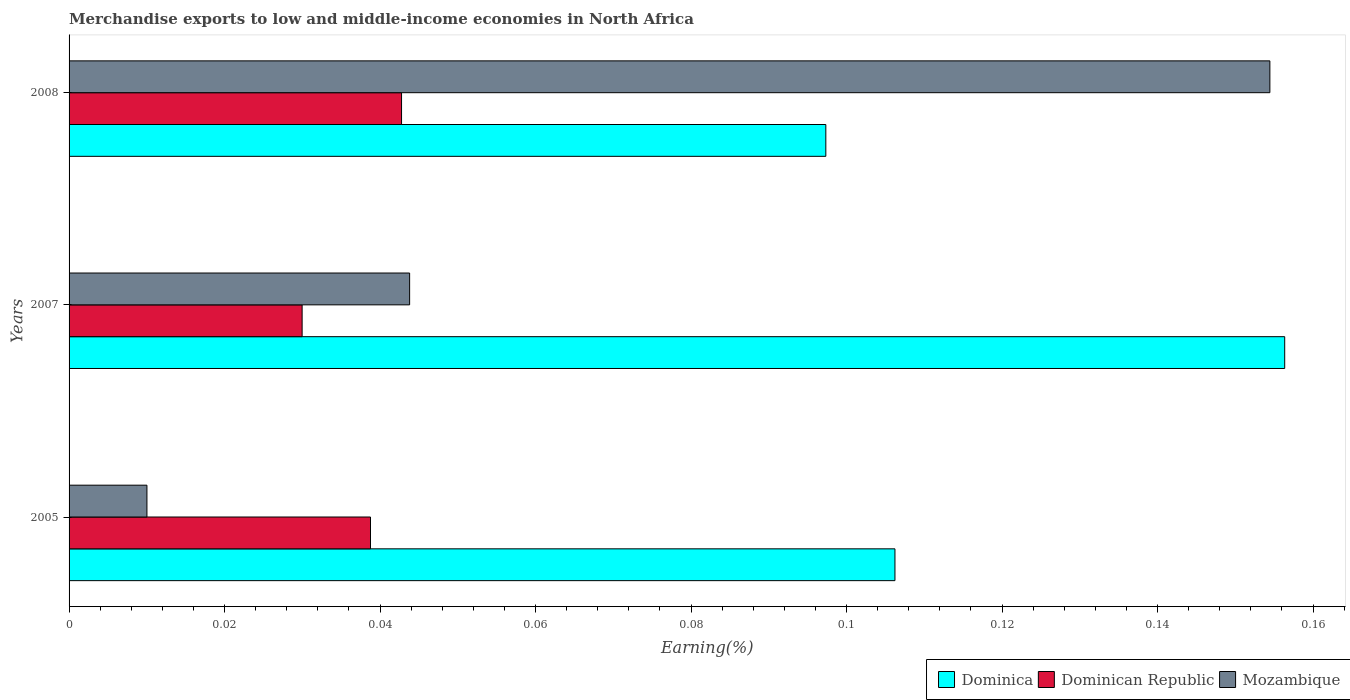How many different coloured bars are there?
Your answer should be very brief. 3. Are the number of bars on each tick of the Y-axis equal?
Your response must be concise. Yes. How many bars are there on the 2nd tick from the bottom?
Your response must be concise. 3. What is the label of the 2nd group of bars from the top?
Your response must be concise. 2007. In how many cases, is the number of bars for a given year not equal to the number of legend labels?
Your response must be concise. 0. What is the percentage of amount earned from merchandise exports in Mozambique in 2005?
Your answer should be compact. 0.01. Across all years, what is the maximum percentage of amount earned from merchandise exports in Dominican Republic?
Make the answer very short. 0.04. Across all years, what is the minimum percentage of amount earned from merchandise exports in Dominica?
Offer a very short reply. 0.1. In which year was the percentage of amount earned from merchandise exports in Mozambique maximum?
Offer a very short reply. 2008. What is the total percentage of amount earned from merchandise exports in Mozambique in the graph?
Provide a short and direct response. 0.21. What is the difference between the percentage of amount earned from merchandise exports in Dominican Republic in 2005 and that in 2008?
Ensure brevity in your answer.  -0. What is the difference between the percentage of amount earned from merchandise exports in Dominican Republic in 2008 and the percentage of amount earned from merchandise exports in Mozambique in 2007?
Your answer should be very brief. -0. What is the average percentage of amount earned from merchandise exports in Mozambique per year?
Your answer should be very brief. 0.07. In the year 2008, what is the difference between the percentage of amount earned from merchandise exports in Dominica and percentage of amount earned from merchandise exports in Dominican Republic?
Offer a very short reply. 0.05. What is the ratio of the percentage of amount earned from merchandise exports in Dominica in 2005 to that in 2008?
Give a very brief answer. 1.09. What is the difference between the highest and the second highest percentage of amount earned from merchandise exports in Dominican Republic?
Ensure brevity in your answer.  0. What is the difference between the highest and the lowest percentage of amount earned from merchandise exports in Dominica?
Your response must be concise. 0.06. Is the sum of the percentage of amount earned from merchandise exports in Dominican Republic in 2005 and 2007 greater than the maximum percentage of amount earned from merchandise exports in Mozambique across all years?
Provide a short and direct response. No. What does the 3rd bar from the top in 2007 represents?
Offer a very short reply. Dominica. What does the 3rd bar from the bottom in 2007 represents?
Offer a very short reply. Mozambique. How many bars are there?
Ensure brevity in your answer.  9. Are all the bars in the graph horizontal?
Your answer should be very brief. Yes. How many years are there in the graph?
Provide a short and direct response. 3. What is the difference between two consecutive major ticks on the X-axis?
Provide a succinct answer. 0.02. Does the graph contain any zero values?
Offer a terse response. No. Does the graph contain grids?
Give a very brief answer. No. How many legend labels are there?
Provide a succinct answer. 3. What is the title of the graph?
Give a very brief answer. Merchandise exports to low and middle-income economies in North Africa. Does "Canada" appear as one of the legend labels in the graph?
Your answer should be very brief. No. What is the label or title of the X-axis?
Your response must be concise. Earning(%). What is the Earning(%) in Dominica in 2005?
Keep it short and to the point. 0.11. What is the Earning(%) of Dominican Republic in 2005?
Provide a short and direct response. 0.04. What is the Earning(%) in Mozambique in 2005?
Provide a short and direct response. 0.01. What is the Earning(%) of Dominica in 2007?
Ensure brevity in your answer.  0.16. What is the Earning(%) of Dominican Republic in 2007?
Give a very brief answer. 0.03. What is the Earning(%) in Mozambique in 2007?
Provide a succinct answer. 0.04. What is the Earning(%) of Dominica in 2008?
Keep it short and to the point. 0.1. What is the Earning(%) of Dominican Republic in 2008?
Give a very brief answer. 0.04. What is the Earning(%) of Mozambique in 2008?
Ensure brevity in your answer.  0.15. Across all years, what is the maximum Earning(%) in Dominica?
Your answer should be compact. 0.16. Across all years, what is the maximum Earning(%) of Dominican Republic?
Provide a short and direct response. 0.04. Across all years, what is the maximum Earning(%) in Mozambique?
Give a very brief answer. 0.15. Across all years, what is the minimum Earning(%) of Dominica?
Your answer should be compact. 0.1. Across all years, what is the minimum Earning(%) of Dominican Republic?
Offer a very short reply. 0.03. Across all years, what is the minimum Earning(%) of Mozambique?
Ensure brevity in your answer.  0.01. What is the total Earning(%) of Dominica in the graph?
Provide a short and direct response. 0.36. What is the total Earning(%) in Dominican Republic in the graph?
Keep it short and to the point. 0.11. What is the total Earning(%) in Mozambique in the graph?
Offer a very short reply. 0.21. What is the difference between the Earning(%) of Dominica in 2005 and that in 2007?
Provide a succinct answer. -0.05. What is the difference between the Earning(%) in Dominican Republic in 2005 and that in 2007?
Make the answer very short. 0.01. What is the difference between the Earning(%) of Mozambique in 2005 and that in 2007?
Make the answer very short. -0.03. What is the difference between the Earning(%) of Dominica in 2005 and that in 2008?
Provide a succinct answer. 0.01. What is the difference between the Earning(%) in Dominican Republic in 2005 and that in 2008?
Ensure brevity in your answer.  -0. What is the difference between the Earning(%) of Mozambique in 2005 and that in 2008?
Your response must be concise. -0.14. What is the difference between the Earning(%) of Dominica in 2007 and that in 2008?
Offer a terse response. 0.06. What is the difference between the Earning(%) of Dominican Republic in 2007 and that in 2008?
Offer a terse response. -0.01. What is the difference between the Earning(%) of Mozambique in 2007 and that in 2008?
Your response must be concise. -0.11. What is the difference between the Earning(%) of Dominica in 2005 and the Earning(%) of Dominican Republic in 2007?
Make the answer very short. 0.08. What is the difference between the Earning(%) in Dominica in 2005 and the Earning(%) in Mozambique in 2007?
Your answer should be very brief. 0.06. What is the difference between the Earning(%) of Dominican Republic in 2005 and the Earning(%) of Mozambique in 2007?
Your response must be concise. -0.01. What is the difference between the Earning(%) of Dominica in 2005 and the Earning(%) of Dominican Republic in 2008?
Your answer should be compact. 0.06. What is the difference between the Earning(%) of Dominica in 2005 and the Earning(%) of Mozambique in 2008?
Provide a short and direct response. -0.05. What is the difference between the Earning(%) in Dominican Republic in 2005 and the Earning(%) in Mozambique in 2008?
Keep it short and to the point. -0.12. What is the difference between the Earning(%) of Dominica in 2007 and the Earning(%) of Dominican Republic in 2008?
Ensure brevity in your answer.  0.11. What is the difference between the Earning(%) in Dominica in 2007 and the Earning(%) in Mozambique in 2008?
Your answer should be very brief. 0. What is the difference between the Earning(%) in Dominican Republic in 2007 and the Earning(%) in Mozambique in 2008?
Your answer should be very brief. -0.12. What is the average Earning(%) of Dominica per year?
Ensure brevity in your answer.  0.12. What is the average Earning(%) in Dominican Republic per year?
Provide a short and direct response. 0.04. What is the average Earning(%) in Mozambique per year?
Keep it short and to the point. 0.07. In the year 2005, what is the difference between the Earning(%) of Dominica and Earning(%) of Dominican Republic?
Your response must be concise. 0.07. In the year 2005, what is the difference between the Earning(%) of Dominica and Earning(%) of Mozambique?
Offer a terse response. 0.1. In the year 2005, what is the difference between the Earning(%) in Dominican Republic and Earning(%) in Mozambique?
Offer a terse response. 0.03. In the year 2007, what is the difference between the Earning(%) in Dominica and Earning(%) in Dominican Republic?
Your answer should be very brief. 0.13. In the year 2007, what is the difference between the Earning(%) of Dominica and Earning(%) of Mozambique?
Give a very brief answer. 0.11. In the year 2007, what is the difference between the Earning(%) of Dominican Republic and Earning(%) of Mozambique?
Ensure brevity in your answer.  -0.01. In the year 2008, what is the difference between the Earning(%) in Dominica and Earning(%) in Dominican Republic?
Provide a short and direct response. 0.05. In the year 2008, what is the difference between the Earning(%) in Dominica and Earning(%) in Mozambique?
Provide a short and direct response. -0.06. In the year 2008, what is the difference between the Earning(%) in Dominican Republic and Earning(%) in Mozambique?
Your answer should be very brief. -0.11. What is the ratio of the Earning(%) of Dominica in 2005 to that in 2007?
Ensure brevity in your answer.  0.68. What is the ratio of the Earning(%) in Dominican Republic in 2005 to that in 2007?
Your answer should be very brief. 1.29. What is the ratio of the Earning(%) of Mozambique in 2005 to that in 2007?
Keep it short and to the point. 0.23. What is the ratio of the Earning(%) in Dominica in 2005 to that in 2008?
Ensure brevity in your answer.  1.09. What is the ratio of the Earning(%) of Dominican Republic in 2005 to that in 2008?
Keep it short and to the point. 0.91. What is the ratio of the Earning(%) of Mozambique in 2005 to that in 2008?
Ensure brevity in your answer.  0.06. What is the ratio of the Earning(%) in Dominica in 2007 to that in 2008?
Your response must be concise. 1.61. What is the ratio of the Earning(%) in Dominican Republic in 2007 to that in 2008?
Your response must be concise. 0.7. What is the ratio of the Earning(%) of Mozambique in 2007 to that in 2008?
Your answer should be compact. 0.28. What is the difference between the highest and the second highest Earning(%) in Dominica?
Your answer should be compact. 0.05. What is the difference between the highest and the second highest Earning(%) of Dominican Republic?
Give a very brief answer. 0. What is the difference between the highest and the second highest Earning(%) in Mozambique?
Offer a very short reply. 0.11. What is the difference between the highest and the lowest Earning(%) of Dominica?
Keep it short and to the point. 0.06. What is the difference between the highest and the lowest Earning(%) of Dominican Republic?
Your answer should be very brief. 0.01. What is the difference between the highest and the lowest Earning(%) in Mozambique?
Ensure brevity in your answer.  0.14. 